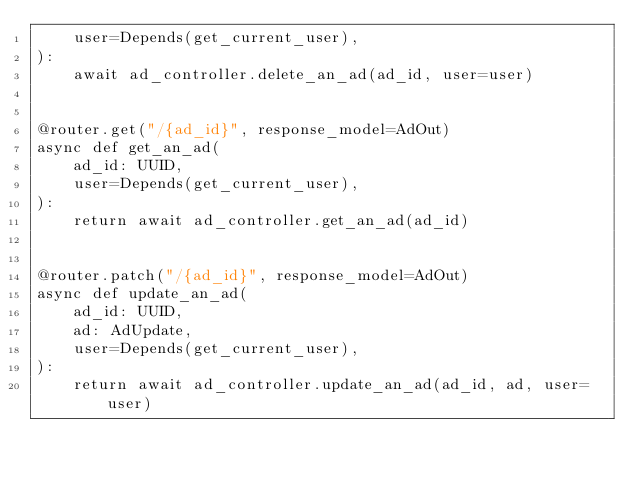Convert code to text. <code><loc_0><loc_0><loc_500><loc_500><_Python_>    user=Depends(get_current_user),
):
    await ad_controller.delete_an_ad(ad_id, user=user)


@router.get("/{ad_id}", response_model=AdOut)
async def get_an_ad(
    ad_id: UUID,
    user=Depends(get_current_user),
):
    return await ad_controller.get_an_ad(ad_id)


@router.patch("/{ad_id}", response_model=AdOut)
async def update_an_ad(
    ad_id: UUID,
    ad: AdUpdate,
    user=Depends(get_current_user),
):
    return await ad_controller.update_an_ad(ad_id, ad, user=user)
</code> 